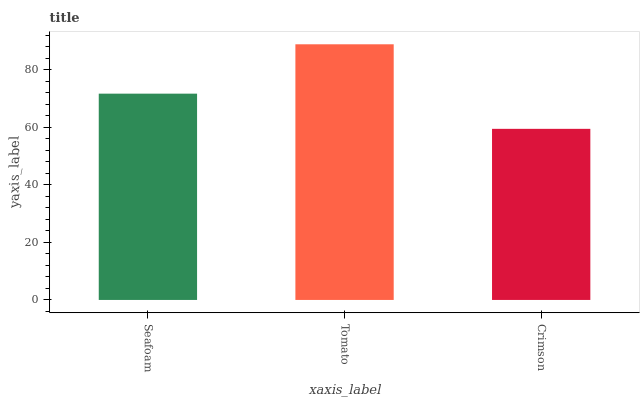Is Crimson the minimum?
Answer yes or no. Yes. Is Tomato the maximum?
Answer yes or no. Yes. Is Tomato the minimum?
Answer yes or no. No. Is Crimson the maximum?
Answer yes or no. No. Is Tomato greater than Crimson?
Answer yes or no. Yes. Is Crimson less than Tomato?
Answer yes or no. Yes. Is Crimson greater than Tomato?
Answer yes or no. No. Is Tomato less than Crimson?
Answer yes or no. No. Is Seafoam the high median?
Answer yes or no. Yes. Is Seafoam the low median?
Answer yes or no. Yes. Is Tomato the high median?
Answer yes or no. No. Is Crimson the low median?
Answer yes or no. No. 